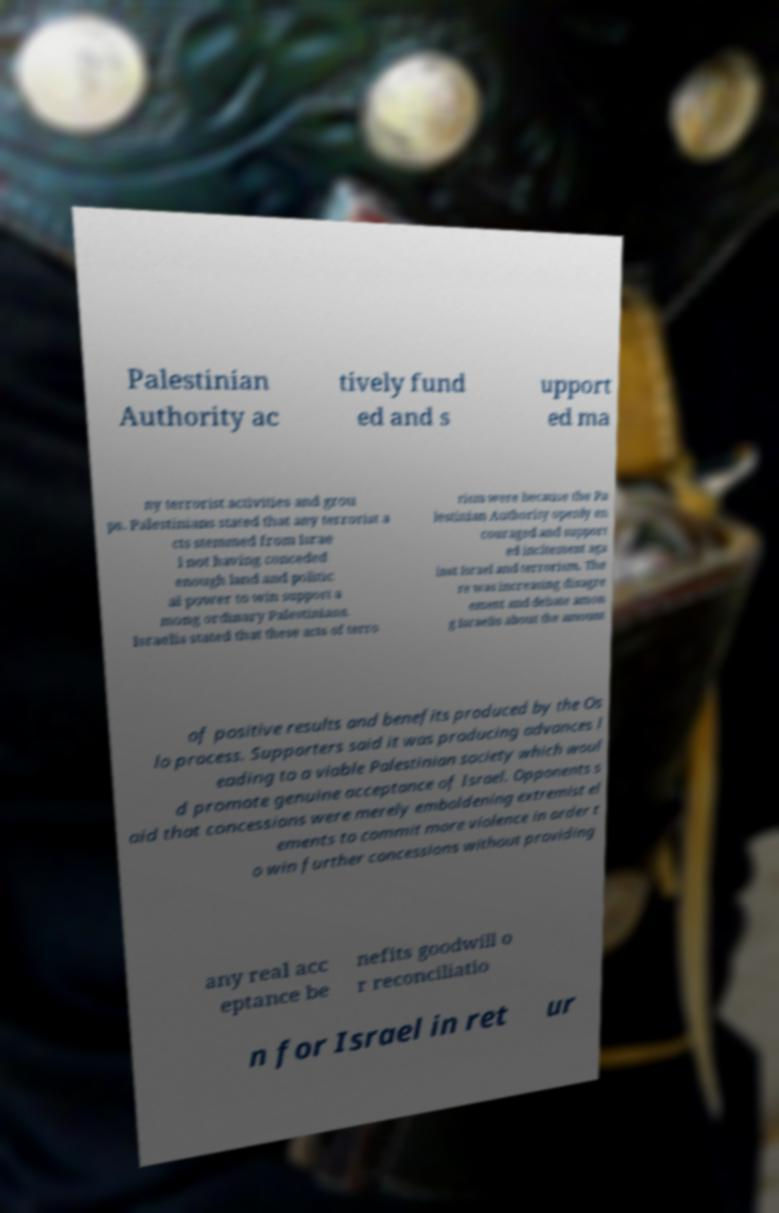Can you accurately transcribe the text from the provided image for me? Palestinian Authority ac tively fund ed and s upport ed ma ny terrorist activities and grou ps. Palestinians stated that any terrorist a cts stemmed from Israe l not having conceded enough land and politic al power to win support a mong ordinary Palestinians. Israelis stated that these acts of terro rism were because the Pa lestinian Authority openly en couraged and support ed incitement aga inst Israel and terrorism. The re was increasing disagre ement and debate amon g Israelis about the amount of positive results and benefits produced by the Os lo process. Supporters said it was producing advances l eading to a viable Palestinian society which woul d promote genuine acceptance of Israel. Opponents s aid that concessions were merely emboldening extremist el ements to commit more violence in order t o win further concessions without providing any real acc eptance be nefits goodwill o r reconciliatio n for Israel in ret ur 